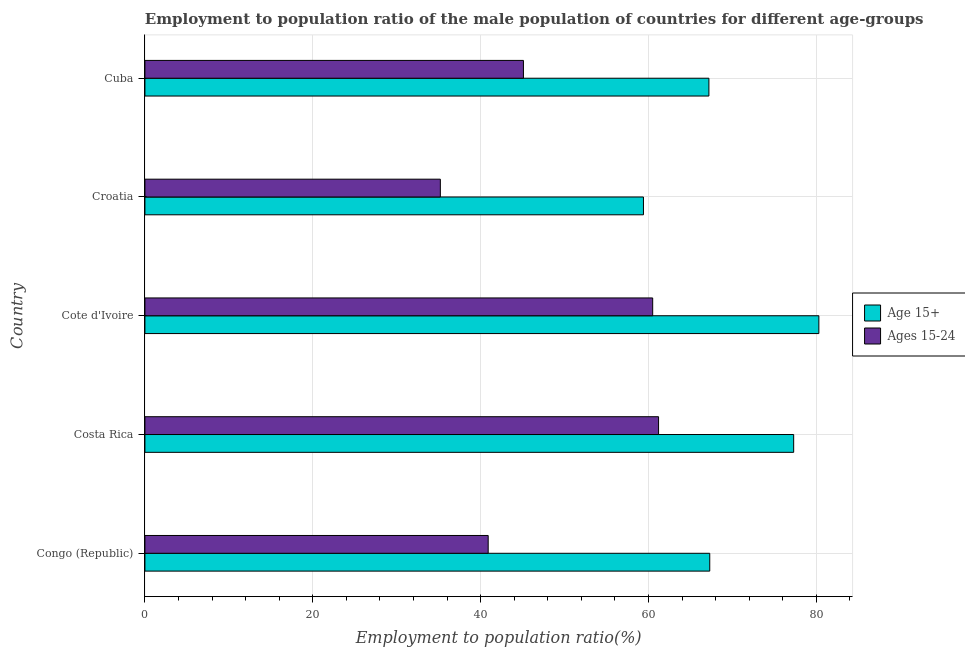How many different coloured bars are there?
Provide a short and direct response. 2. Are the number of bars per tick equal to the number of legend labels?
Keep it short and to the point. Yes. How many bars are there on the 1st tick from the bottom?
Make the answer very short. 2. What is the label of the 3rd group of bars from the top?
Provide a short and direct response. Cote d'Ivoire. In how many cases, is the number of bars for a given country not equal to the number of legend labels?
Provide a succinct answer. 0. What is the employment to population ratio(age 15-24) in Costa Rica?
Provide a short and direct response. 61.2. Across all countries, what is the maximum employment to population ratio(age 15-24)?
Keep it short and to the point. 61.2. Across all countries, what is the minimum employment to population ratio(age 15+)?
Your answer should be compact. 59.4. In which country was the employment to population ratio(age 15+) maximum?
Provide a succinct answer. Cote d'Ivoire. In which country was the employment to population ratio(age 15-24) minimum?
Ensure brevity in your answer.  Croatia. What is the total employment to population ratio(age 15-24) in the graph?
Provide a short and direct response. 242.9. What is the difference between the employment to population ratio(age 15+) in Congo (Republic) and that in Costa Rica?
Offer a very short reply. -10. What is the difference between the employment to population ratio(age 15+) in Cuba and the employment to population ratio(age 15-24) in Congo (Republic)?
Ensure brevity in your answer.  26.3. What is the average employment to population ratio(age 15+) per country?
Make the answer very short. 70.3. What is the difference between the employment to population ratio(age 15-24) and employment to population ratio(age 15+) in Cote d'Ivoire?
Ensure brevity in your answer.  -19.8. What is the ratio of the employment to population ratio(age 15-24) in Congo (Republic) to that in Cote d'Ivoire?
Your response must be concise. 0.68. Is the difference between the employment to population ratio(age 15+) in Costa Rica and Cuba greater than the difference between the employment to population ratio(age 15-24) in Costa Rica and Cuba?
Your response must be concise. No. What is the difference between the highest and the second highest employment to population ratio(age 15+)?
Offer a very short reply. 3. What is the difference between the highest and the lowest employment to population ratio(age 15+)?
Provide a short and direct response. 20.9. What does the 2nd bar from the top in Cote d'Ivoire represents?
Ensure brevity in your answer.  Age 15+. What does the 1st bar from the bottom in Cote d'Ivoire represents?
Offer a very short reply. Age 15+. Does the graph contain grids?
Provide a short and direct response. Yes. Where does the legend appear in the graph?
Your response must be concise. Center right. How many legend labels are there?
Keep it short and to the point. 2. How are the legend labels stacked?
Offer a very short reply. Vertical. What is the title of the graph?
Give a very brief answer. Employment to population ratio of the male population of countries for different age-groups. What is the Employment to population ratio(%) in Age 15+ in Congo (Republic)?
Ensure brevity in your answer.  67.3. What is the Employment to population ratio(%) of Ages 15-24 in Congo (Republic)?
Your response must be concise. 40.9. What is the Employment to population ratio(%) of Age 15+ in Costa Rica?
Your answer should be very brief. 77.3. What is the Employment to population ratio(%) of Ages 15-24 in Costa Rica?
Ensure brevity in your answer.  61.2. What is the Employment to population ratio(%) in Age 15+ in Cote d'Ivoire?
Offer a terse response. 80.3. What is the Employment to population ratio(%) of Ages 15-24 in Cote d'Ivoire?
Provide a short and direct response. 60.5. What is the Employment to population ratio(%) in Age 15+ in Croatia?
Provide a succinct answer. 59.4. What is the Employment to population ratio(%) in Ages 15-24 in Croatia?
Your response must be concise. 35.2. What is the Employment to population ratio(%) in Age 15+ in Cuba?
Make the answer very short. 67.2. What is the Employment to population ratio(%) in Ages 15-24 in Cuba?
Ensure brevity in your answer.  45.1. Across all countries, what is the maximum Employment to population ratio(%) of Age 15+?
Make the answer very short. 80.3. Across all countries, what is the maximum Employment to population ratio(%) in Ages 15-24?
Your answer should be compact. 61.2. Across all countries, what is the minimum Employment to population ratio(%) of Age 15+?
Your response must be concise. 59.4. Across all countries, what is the minimum Employment to population ratio(%) of Ages 15-24?
Ensure brevity in your answer.  35.2. What is the total Employment to population ratio(%) of Age 15+ in the graph?
Keep it short and to the point. 351.5. What is the total Employment to population ratio(%) of Ages 15-24 in the graph?
Give a very brief answer. 242.9. What is the difference between the Employment to population ratio(%) in Age 15+ in Congo (Republic) and that in Costa Rica?
Your answer should be compact. -10. What is the difference between the Employment to population ratio(%) in Ages 15-24 in Congo (Republic) and that in Costa Rica?
Provide a short and direct response. -20.3. What is the difference between the Employment to population ratio(%) of Ages 15-24 in Congo (Republic) and that in Cote d'Ivoire?
Your answer should be compact. -19.6. What is the difference between the Employment to population ratio(%) in Ages 15-24 in Congo (Republic) and that in Croatia?
Your response must be concise. 5.7. What is the difference between the Employment to population ratio(%) of Age 15+ in Congo (Republic) and that in Cuba?
Your answer should be very brief. 0.1. What is the difference between the Employment to population ratio(%) of Age 15+ in Costa Rica and that in Cote d'Ivoire?
Your answer should be compact. -3. What is the difference between the Employment to population ratio(%) of Ages 15-24 in Costa Rica and that in Croatia?
Offer a very short reply. 26. What is the difference between the Employment to population ratio(%) in Ages 15-24 in Costa Rica and that in Cuba?
Give a very brief answer. 16.1. What is the difference between the Employment to population ratio(%) of Age 15+ in Cote d'Ivoire and that in Croatia?
Keep it short and to the point. 20.9. What is the difference between the Employment to population ratio(%) in Ages 15-24 in Cote d'Ivoire and that in Croatia?
Provide a short and direct response. 25.3. What is the difference between the Employment to population ratio(%) in Age 15+ in Cote d'Ivoire and that in Cuba?
Provide a short and direct response. 13.1. What is the difference between the Employment to population ratio(%) in Ages 15-24 in Cote d'Ivoire and that in Cuba?
Your answer should be compact. 15.4. What is the difference between the Employment to population ratio(%) of Age 15+ in Congo (Republic) and the Employment to population ratio(%) of Ages 15-24 in Croatia?
Keep it short and to the point. 32.1. What is the difference between the Employment to population ratio(%) of Age 15+ in Costa Rica and the Employment to population ratio(%) of Ages 15-24 in Croatia?
Provide a short and direct response. 42.1. What is the difference between the Employment to population ratio(%) of Age 15+ in Costa Rica and the Employment to population ratio(%) of Ages 15-24 in Cuba?
Make the answer very short. 32.2. What is the difference between the Employment to population ratio(%) in Age 15+ in Cote d'Ivoire and the Employment to population ratio(%) in Ages 15-24 in Croatia?
Give a very brief answer. 45.1. What is the difference between the Employment to population ratio(%) of Age 15+ in Cote d'Ivoire and the Employment to population ratio(%) of Ages 15-24 in Cuba?
Your answer should be very brief. 35.2. What is the average Employment to population ratio(%) in Age 15+ per country?
Give a very brief answer. 70.3. What is the average Employment to population ratio(%) of Ages 15-24 per country?
Make the answer very short. 48.58. What is the difference between the Employment to population ratio(%) in Age 15+ and Employment to population ratio(%) in Ages 15-24 in Congo (Republic)?
Ensure brevity in your answer.  26.4. What is the difference between the Employment to population ratio(%) of Age 15+ and Employment to population ratio(%) of Ages 15-24 in Cote d'Ivoire?
Your answer should be compact. 19.8. What is the difference between the Employment to population ratio(%) in Age 15+ and Employment to population ratio(%) in Ages 15-24 in Croatia?
Your response must be concise. 24.2. What is the difference between the Employment to population ratio(%) in Age 15+ and Employment to population ratio(%) in Ages 15-24 in Cuba?
Ensure brevity in your answer.  22.1. What is the ratio of the Employment to population ratio(%) in Age 15+ in Congo (Republic) to that in Costa Rica?
Your response must be concise. 0.87. What is the ratio of the Employment to population ratio(%) of Ages 15-24 in Congo (Republic) to that in Costa Rica?
Your response must be concise. 0.67. What is the ratio of the Employment to population ratio(%) in Age 15+ in Congo (Republic) to that in Cote d'Ivoire?
Make the answer very short. 0.84. What is the ratio of the Employment to population ratio(%) in Ages 15-24 in Congo (Republic) to that in Cote d'Ivoire?
Keep it short and to the point. 0.68. What is the ratio of the Employment to population ratio(%) of Age 15+ in Congo (Republic) to that in Croatia?
Ensure brevity in your answer.  1.13. What is the ratio of the Employment to population ratio(%) in Ages 15-24 in Congo (Republic) to that in Croatia?
Offer a terse response. 1.16. What is the ratio of the Employment to population ratio(%) in Ages 15-24 in Congo (Republic) to that in Cuba?
Keep it short and to the point. 0.91. What is the ratio of the Employment to population ratio(%) in Age 15+ in Costa Rica to that in Cote d'Ivoire?
Your response must be concise. 0.96. What is the ratio of the Employment to population ratio(%) in Ages 15-24 in Costa Rica to that in Cote d'Ivoire?
Give a very brief answer. 1.01. What is the ratio of the Employment to population ratio(%) in Age 15+ in Costa Rica to that in Croatia?
Ensure brevity in your answer.  1.3. What is the ratio of the Employment to population ratio(%) in Ages 15-24 in Costa Rica to that in Croatia?
Offer a terse response. 1.74. What is the ratio of the Employment to population ratio(%) in Age 15+ in Costa Rica to that in Cuba?
Make the answer very short. 1.15. What is the ratio of the Employment to population ratio(%) in Ages 15-24 in Costa Rica to that in Cuba?
Give a very brief answer. 1.36. What is the ratio of the Employment to population ratio(%) of Age 15+ in Cote d'Ivoire to that in Croatia?
Your answer should be compact. 1.35. What is the ratio of the Employment to population ratio(%) in Ages 15-24 in Cote d'Ivoire to that in Croatia?
Provide a short and direct response. 1.72. What is the ratio of the Employment to population ratio(%) of Age 15+ in Cote d'Ivoire to that in Cuba?
Give a very brief answer. 1.19. What is the ratio of the Employment to population ratio(%) of Ages 15-24 in Cote d'Ivoire to that in Cuba?
Ensure brevity in your answer.  1.34. What is the ratio of the Employment to population ratio(%) in Age 15+ in Croatia to that in Cuba?
Give a very brief answer. 0.88. What is the ratio of the Employment to population ratio(%) in Ages 15-24 in Croatia to that in Cuba?
Your response must be concise. 0.78. What is the difference between the highest and the second highest Employment to population ratio(%) of Age 15+?
Your response must be concise. 3. What is the difference between the highest and the second highest Employment to population ratio(%) of Ages 15-24?
Your answer should be compact. 0.7. What is the difference between the highest and the lowest Employment to population ratio(%) in Age 15+?
Your response must be concise. 20.9. 